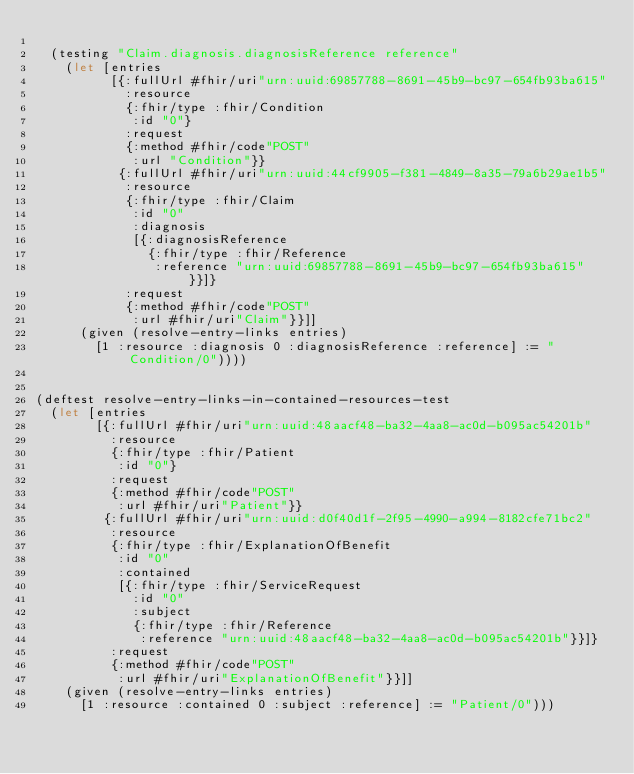Convert code to text. <code><loc_0><loc_0><loc_500><loc_500><_Clojure_>
  (testing "Claim.diagnosis.diagnosisReference reference"
    (let [entries
          [{:fullUrl #fhir/uri"urn:uuid:69857788-8691-45b9-bc97-654fb93ba615"
            :resource
            {:fhir/type :fhir/Condition
             :id "0"}
            :request
            {:method #fhir/code"POST"
             :url "Condition"}}
           {:fullUrl #fhir/uri"urn:uuid:44cf9905-f381-4849-8a35-79a6b29ae1b5"
            :resource
            {:fhir/type :fhir/Claim
             :id "0"
             :diagnosis
             [{:diagnosisReference
               {:fhir/type :fhir/Reference
                :reference "urn:uuid:69857788-8691-45b9-bc97-654fb93ba615"}}]}
            :request
            {:method #fhir/code"POST"
             :url #fhir/uri"Claim"}}]]
      (given (resolve-entry-links entries)
        [1 :resource :diagnosis 0 :diagnosisReference :reference] := "Condition/0"))))


(deftest resolve-entry-links-in-contained-resources-test
  (let [entries
        [{:fullUrl #fhir/uri"urn:uuid:48aacf48-ba32-4aa8-ac0d-b095ac54201b"
          :resource
          {:fhir/type :fhir/Patient
           :id "0"}
          :request
          {:method #fhir/code"POST"
           :url #fhir/uri"Patient"}}
         {:fullUrl #fhir/uri"urn:uuid:d0f40d1f-2f95-4990-a994-8182cfe71bc2"
          :resource
          {:fhir/type :fhir/ExplanationOfBenefit
           :id "0"
           :contained
           [{:fhir/type :fhir/ServiceRequest
             :id "0"
             :subject
             {:fhir/type :fhir/Reference
              :reference "urn:uuid:48aacf48-ba32-4aa8-ac0d-b095ac54201b"}}]}
          :request
          {:method #fhir/code"POST"
           :url #fhir/uri"ExplanationOfBenefit"}}]]
    (given (resolve-entry-links entries)
      [1 :resource :contained 0 :subject :reference] := "Patient/0")))
</code> 